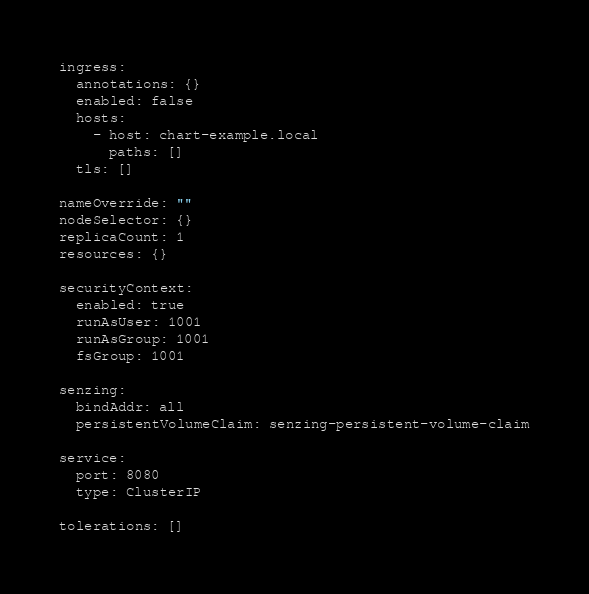<code> <loc_0><loc_0><loc_500><loc_500><_YAML_>ingress:
  annotations: {}
  enabled: false
  hosts:
    - host: chart-example.local
      paths: []
  tls: []

nameOverride: ""
nodeSelector: {}
replicaCount: 1
resources: {}

securityContext:
  enabled: true
  runAsUser: 1001
  runAsGroup: 1001
  fsGroup: 1001

senzing:
  bindAddr: all
  persistentVolumeClaim: senzing-persistent-volume-claim

service:
  port: 8080
  type: ClusterIP

tolerations: []
</code> 